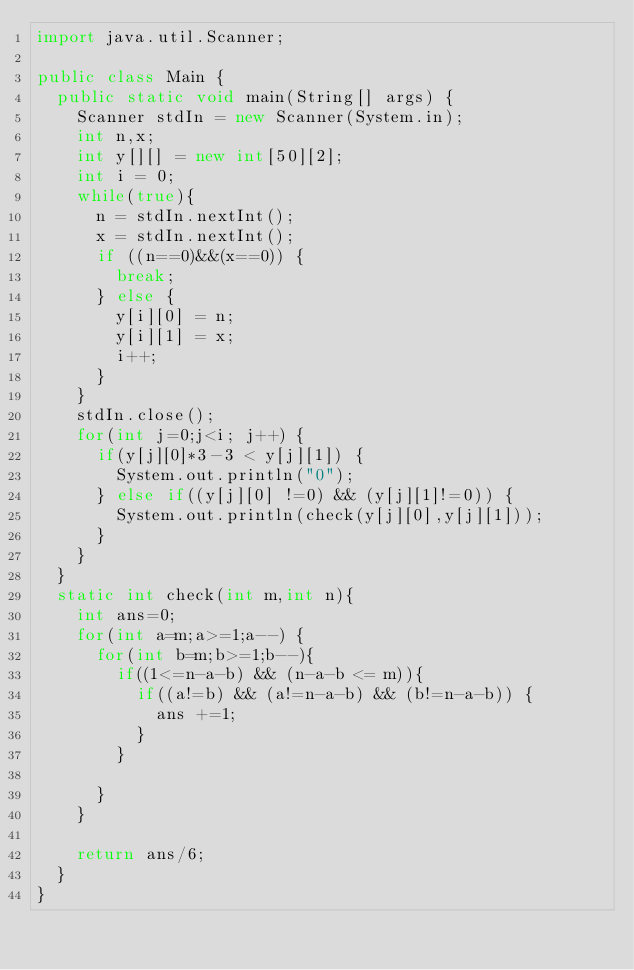<code> <loc_0><loc_0><loc_500><loc_500><_Java_>import java.util.Scanner;

public class Main {
	public static void main(String[] args) {
		Scanner stdIn = new Scanner(System.in);
		int n,x;
		int y[][] = new int[50][2];
		int i = 0;
		while(true){
			n = stdIn.nextInt();
			x = stdIn.nextInt();
			if ((n==0)&&(x==0)) {
				break;
			} else {
				y[i][0] = n;
				y[i][1] = x;
				i++;
			}
		}
		stdIn.close();
		for(int j=0;j<i; j++) {
			if(y[j][0]*3-3 < y[j][1]) {
				System.out.println("0");
			} else if((y[j][0] !=0) && (y[j][1]!=0)) {
				System.out.println(check(y[j][0],y[j][1]));
			}
		}
	}
	static int check(int m,int n){
		int ans=0;
		for(int a=m;a>=1;a--) {
			for(int b=m;b>=1;b--){
				if((1<=n-a-b) && (n-a-b <= m)){
					if((a!=b) && (a!=n-a-b) && (b!=n-a-b)) {
						ans +=1;
					}
				}

			}
		}

		return ans/6;
	}
}
</code> 